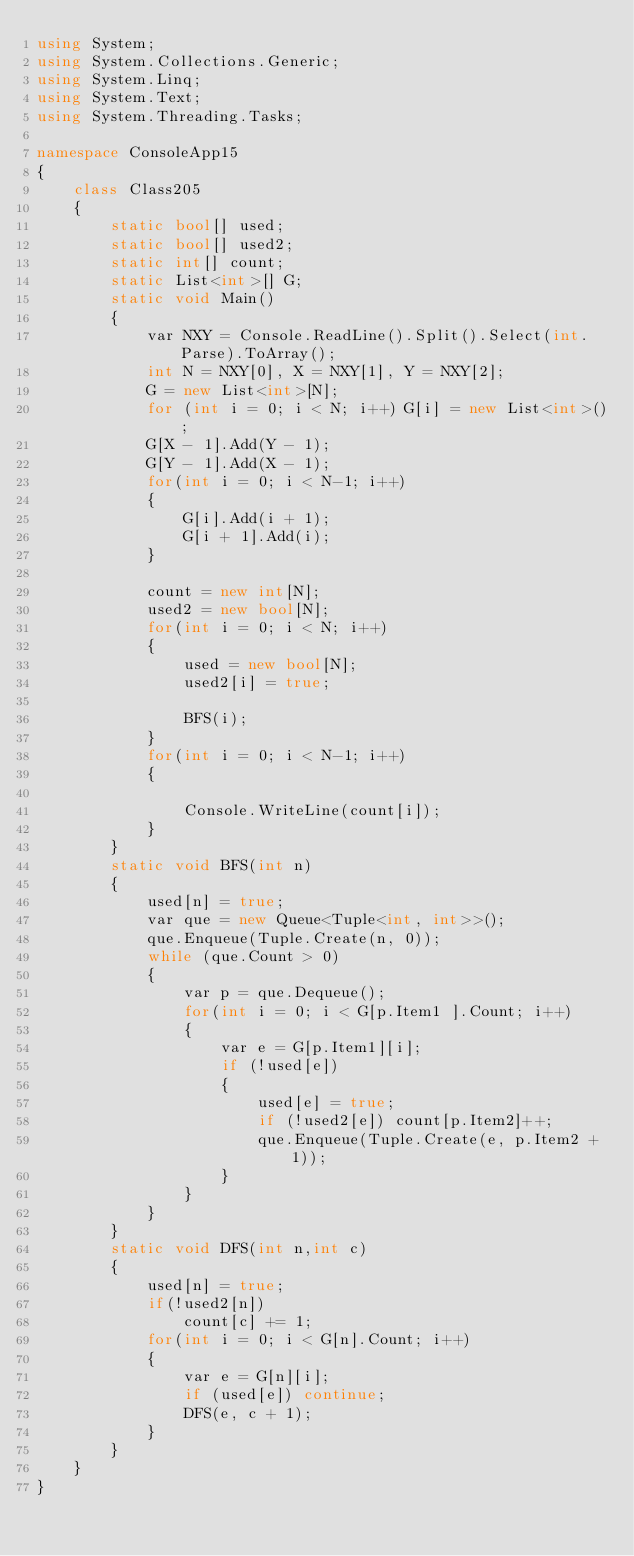<code> <loc_0><loc_0><loc_500><loc_500><_C#_>using System;
using System.Collections.Generic;
using System.Linq;
using System.Text;
using System.Threading.Tasks;

namespace ConsoleApp15
{
    class Class205
    {
        static bool[] used;
        static bool[] used2;
        static int[] count;
        static List<int>[] G;
        static void Main()
        {
            var NXY = Console.ReadLine().Split().Select(int.Parse).ToArray();
            int N = NXY[0], X = NXY[1], Y = NXY[2];
            G = new List<int>[N];
            for (int i = 0; i < N; i++) G[i] = new List<int>();
            G[X - 1].Add(Y - 1);
            G[Y - 1].Add(X - 1);
            for(int i = 0; i < N-1; i++)
            {
                G[i].Add(i + 1);
                G[i + 1].Add(i);
            }

            count = new int[N];
            used2 = new bool[N];
            for(int i = 0; i < N; i++)
            {
                used = new bool[N];
                used2[i] = true;

                BFS(i);
            }
            for(int i = 0; i < N-1; i++)
            {
                
                Console.WriteLine(count[i]);
            }
        }
        static void BFS(int n)
        {
            used[n] = true;
            var que = new Queue<Tuple<int, int>>();
            que.Enqueue(Tuple.Create(n, 0));
            while (que.Count > 0)
            {
                var p = que.Dequeue();
                for(int i = 0; i < G[p.Item1 ].Count; i++)
                {
                    var e = G[p.Item1][i];
                    if (!used[e])
                    {
                        used[e] = true;
                        if (!used2[e]) count[p.Item2]++;
                        que.Enqueue(Tuple.Create(e, p.Item2 + 1));
                    }
                }
            }
        }
        static void DFS(int n,int c)
        {
            used[n] = true;
            if(!used2[n])
                count[c] += 1;
            for(int i = 0; i < G[n].Count; i++)
            {
                var e = G[n][i];
                if (used[e]) continue;
                DFS(e, c + 1);
            }
        }
    }
}
</code> 